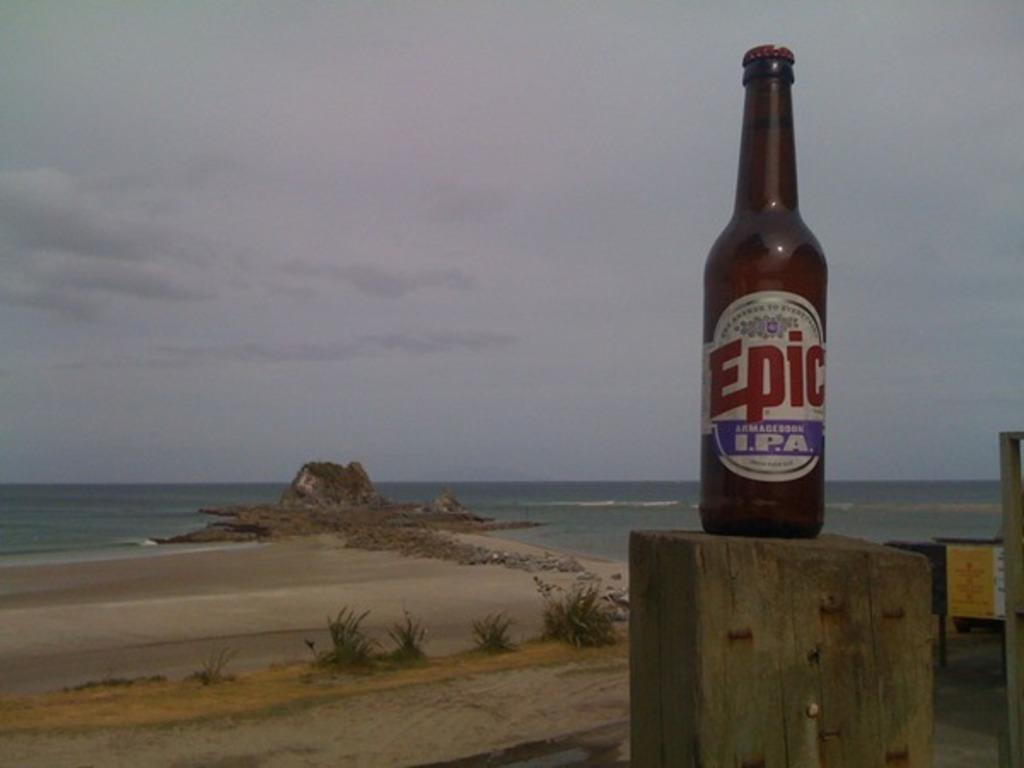What object is present in the image? There is a bottle in the image. What is the bottle placed on? The bottle is on wood. What can be seen in the background of the image? There are plants and water visible in the background of the image. How many arms are visible in the image? There are no arms visible in the image. 